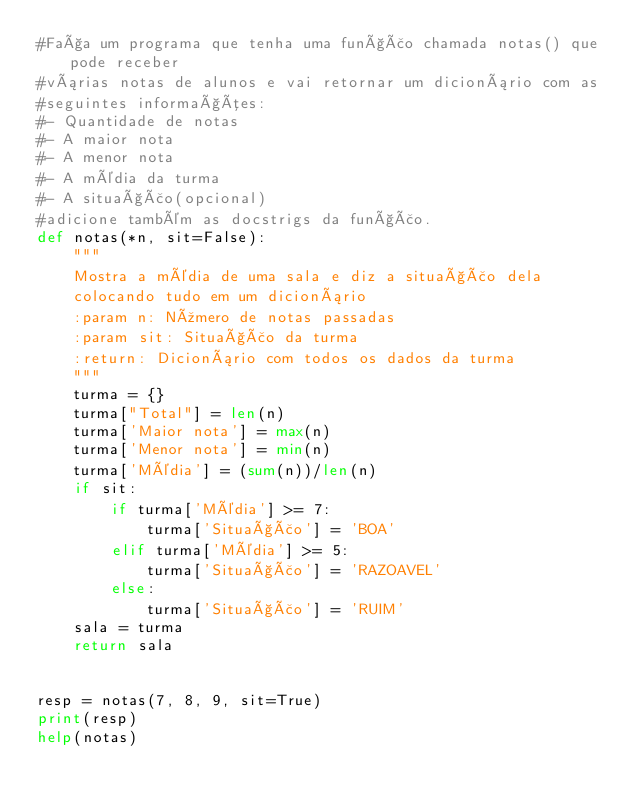Convert code to text. <code><loc_0><loc_0><loc_500><loc_500><_Python_>#Faça um programa que tenha uma função chamada notas() que pode receber
#várias notas de alunos e vai retornar um dicionário com as
#seguintes informações:
#- Quantidade de notas
#- A maior nota
#- A menor nota
#- A média da turma
#- A situação(opcional)
#adicione também as docstrigs da função.
def notas(*n, sit=False):
    """
    Mostra a média de uma sala e diz a situação dela
    colocando tudo em um dicionário
    :param n: Número de notas passadas
    :param sit: Situação da turma
    :return: Dicionário com todos os dados da turma
    """
    turma = {}
    turma["Total"] = len(n)
    turma['Maior nota'] = max(n)
    turma['Menor nota'] = min(n)
    turma['Média'] = (sum(n))/len(n)
    if sit:
        if turma['Média'] >= 7:
            turma['Situação'] = 'BOA'
        elif turma['Média'] >= 5:
            turma['Situação'] = 'RAZOAVEL'
        else:
            turma['Situação'] = 'RUIM'
    sala = turma
    return sala


resp = notas(7, 8, 9, sit=True)
print(resp)
help(notas)
</code> 